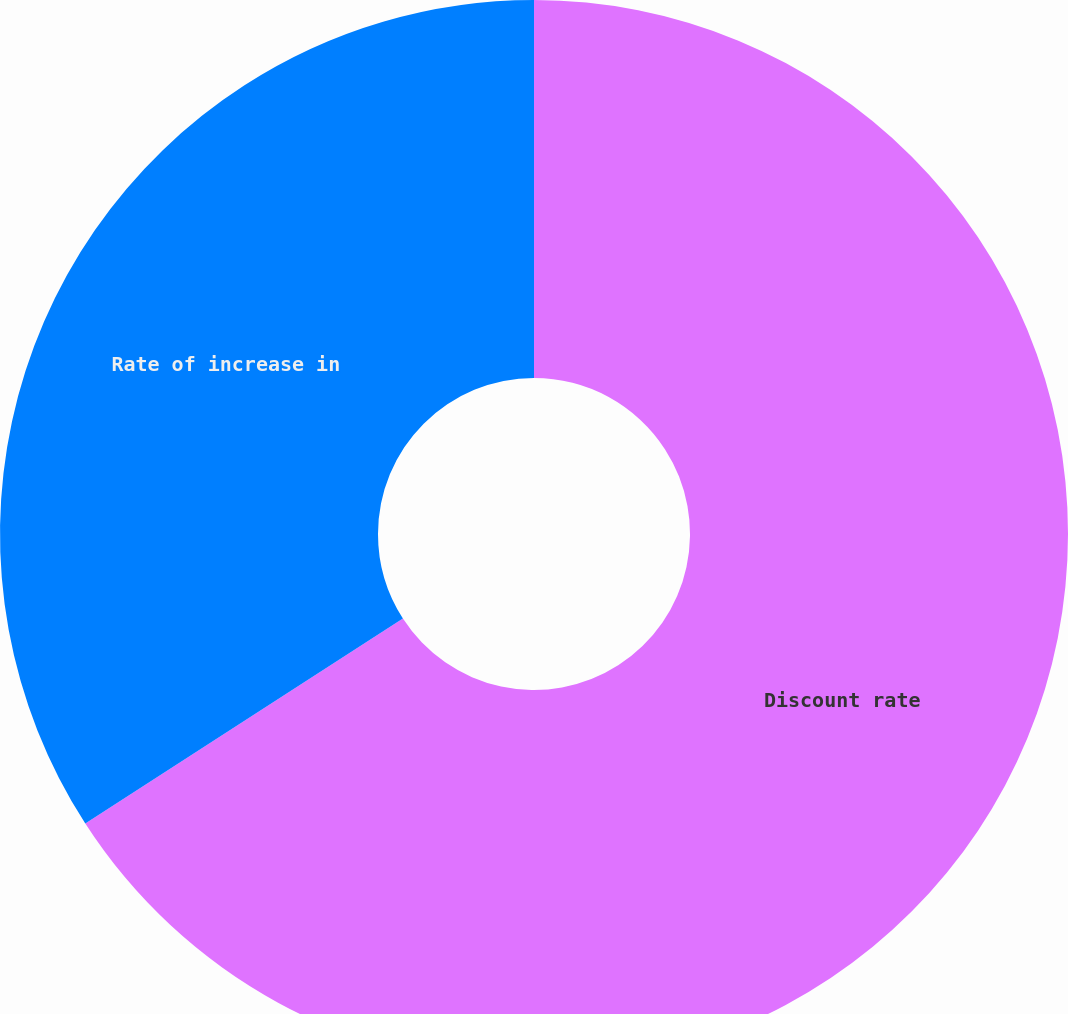Convert chart. <chart><loc_0><loc_0><loc_500><loc_500><pie_chart><fcel>Discount rate<fcel>Rate of increase in<nl><fcel>65.88%<fcel>34.12%<nl></chart> 